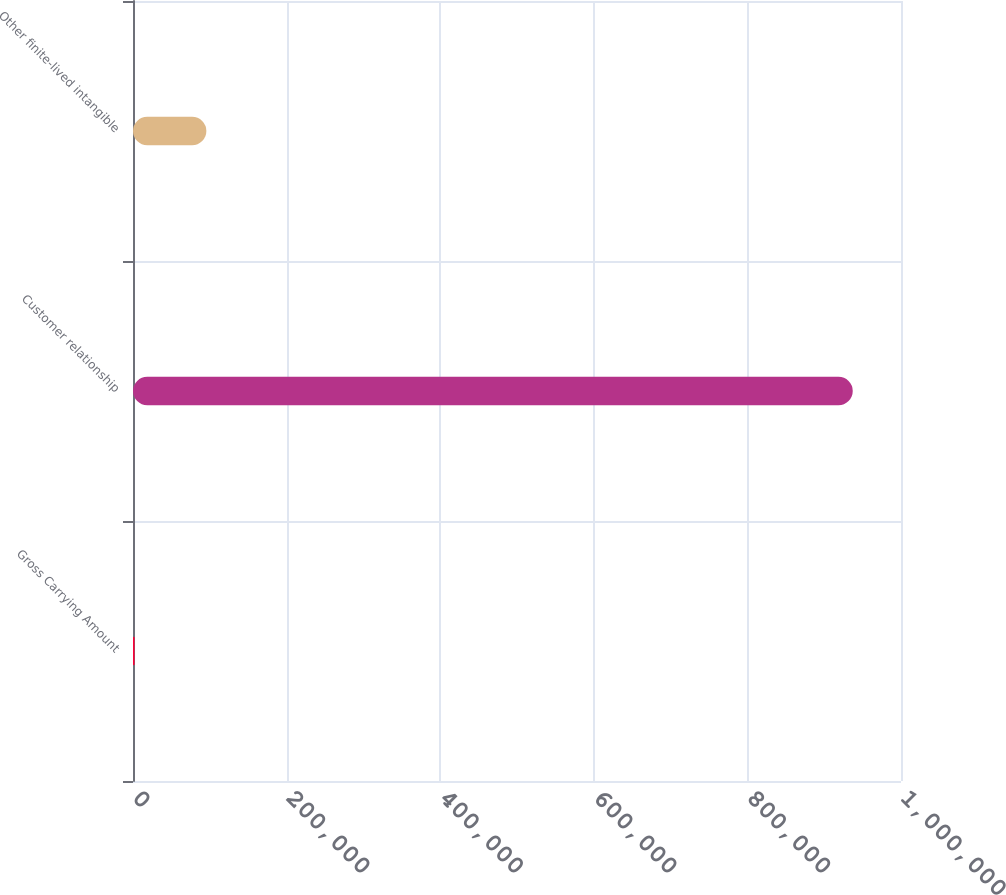<chart> <loc_0><loc_0><loc_500><loc_500><bar_chart><fcel>Gross Carrying Amount<fcel>Customer relationship<fcel>Other finite-lived intangible<nl><fcel>2015<fcel>937174<fcel>95530.9<nl></chart> 